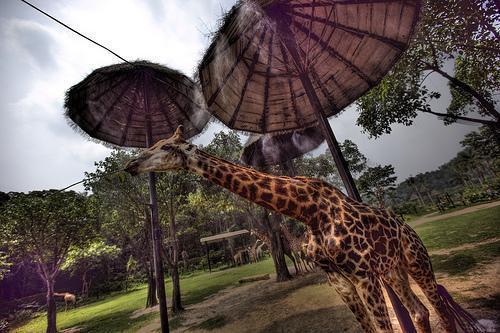How many giraffes are shown?
Give a very brief answer. 7. 